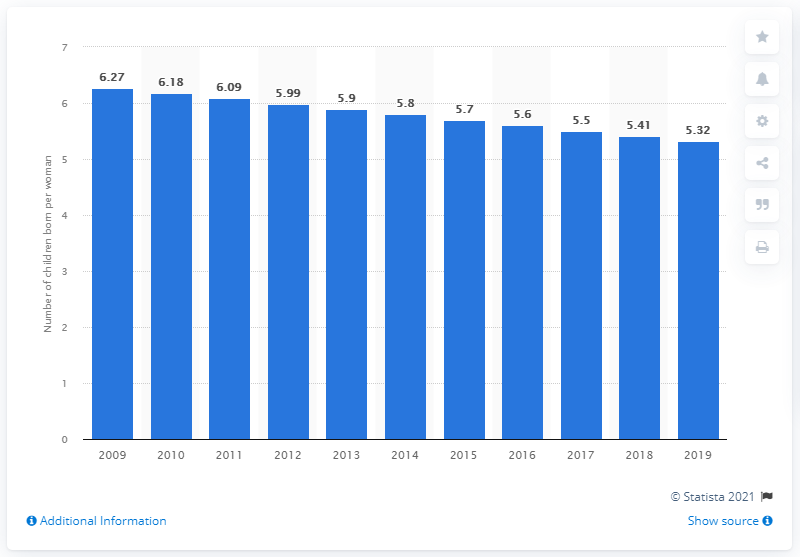Highlight a few significant elements in this photo. The fertility rate in Burundi in 2019 was 5.32. 